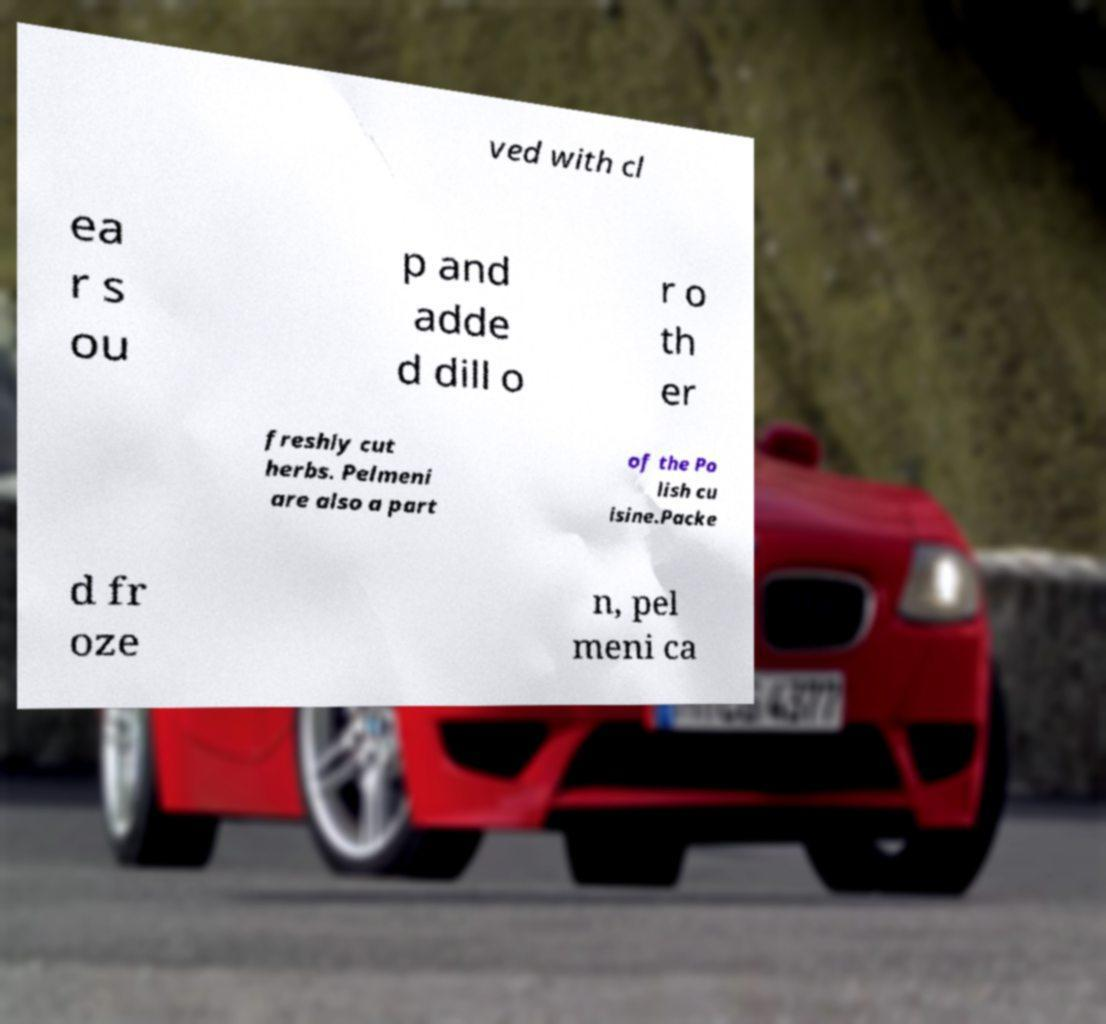What messages or text are displayed in this image? I need them in a readable, typed format. ved with cl ea r s ou p and adde d dill o r o th er freshly cut herbs. Pelmeni are also a part of the Po lish cu isine.Packe d fr oze n, pel meni ca 